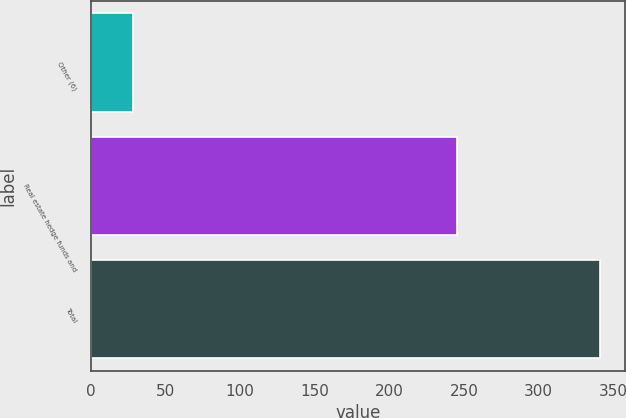<chart> <loc_0><loc_0><loc_500><loc_500><bar_chart><fcel>Other (6)<fcel>Real estate hedge funds and<fcel>Total<nl><fcel>28<fcel>245<fcel>341<nl></chart> 